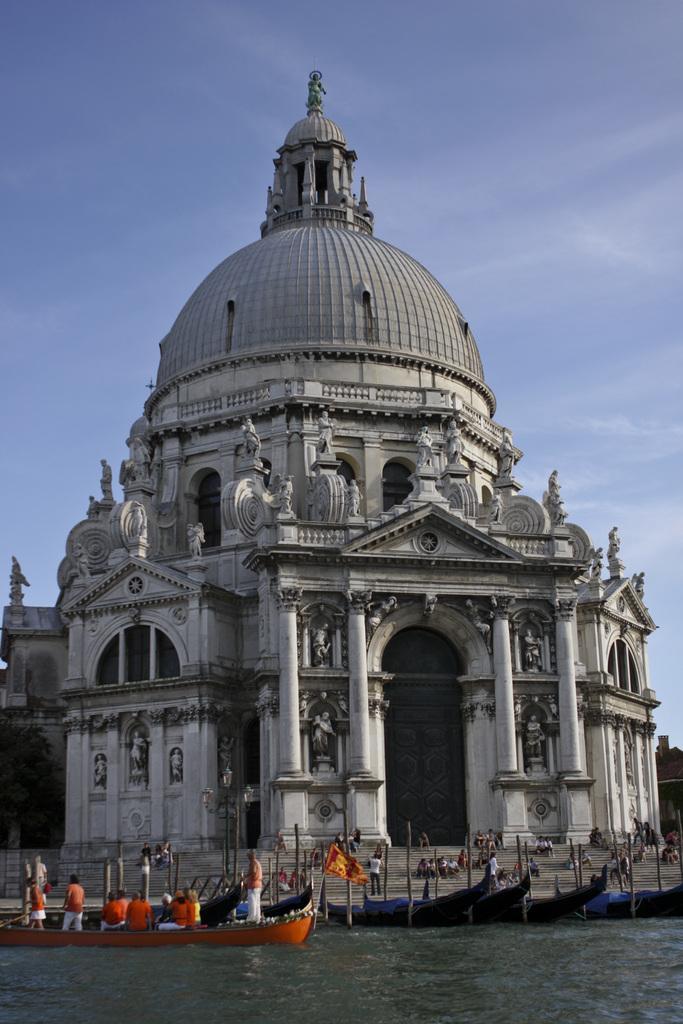Could you give a brief overview of what you see in this image? In the center of the image we can see a building, pillars, door, windows, sculptures. At the bottom of the image we can see the stairs, poles, boats, water and some persons. At the top of the image we can see the clouds are present in the sky. 